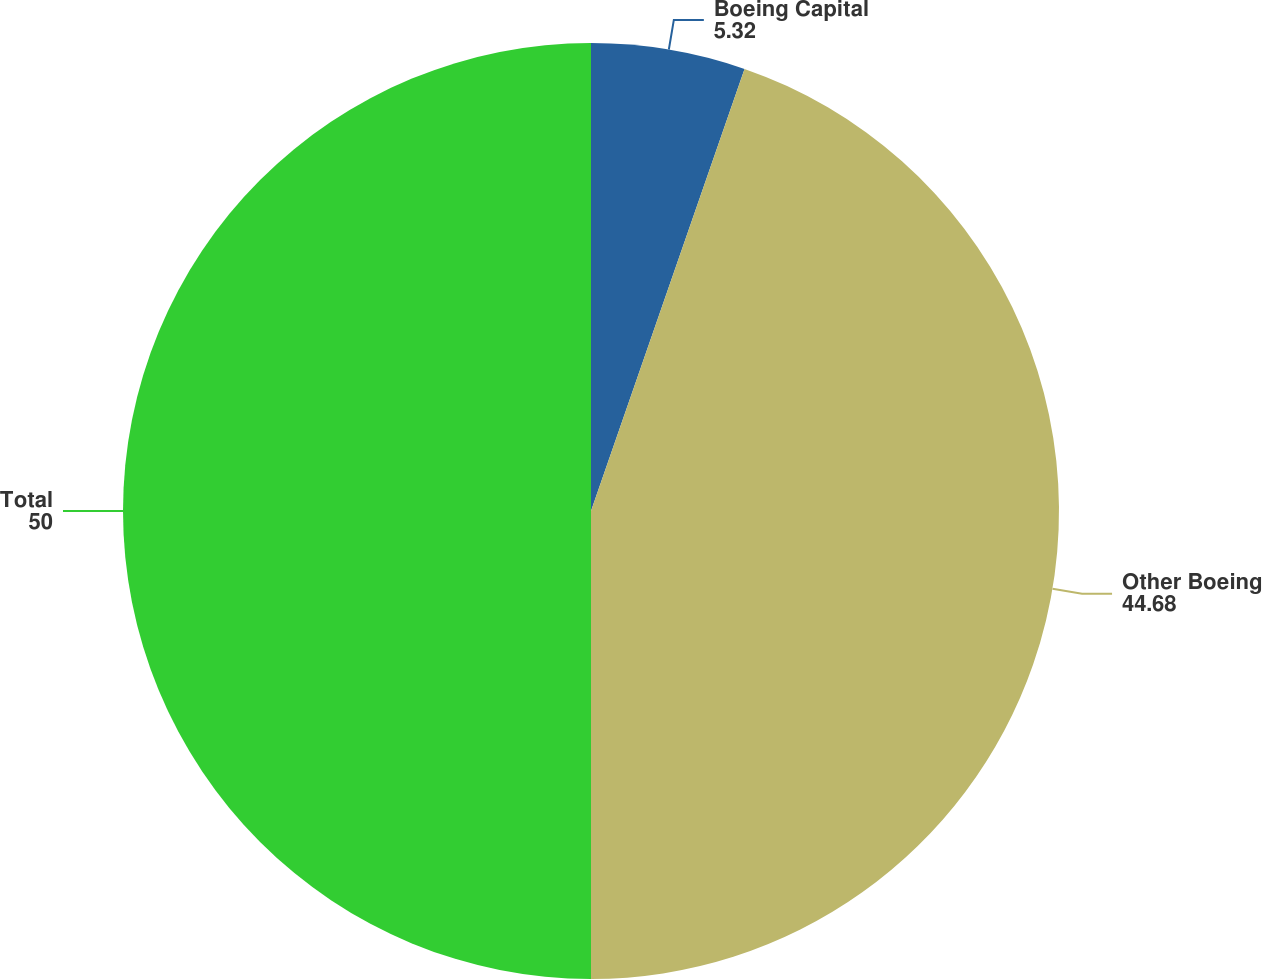Convert chart to OTSL. <chart><loc_0><loc_0><loc_500><loc_500><pie_chart><fcel>Boeing Capital<fcel>Other Boeing<fcel>Total<nl><fcel>5.32%<fcel>44.68%<fcel>50.0%<nl></chart> 